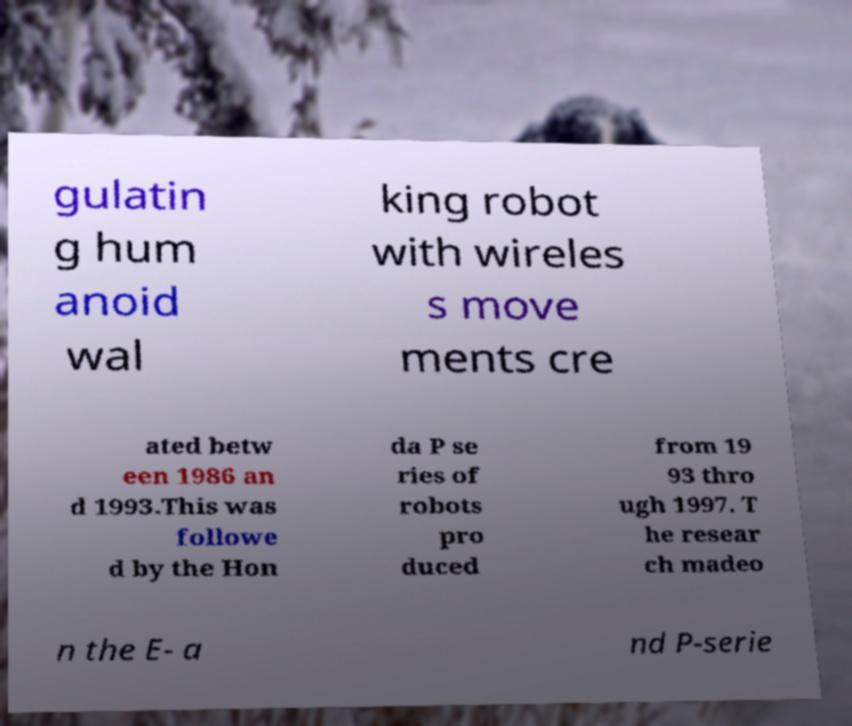Could you extract and type out the text from this image? gulatin g hum anoid wal king robot with wireles s move ments cre ated betw een 1986 an d 1993.This was followe d by the Hon da P se ries of robots pro duced from 19 93 thro ugh 1997. T he resear ch madeo n the E- a nd P-serie 